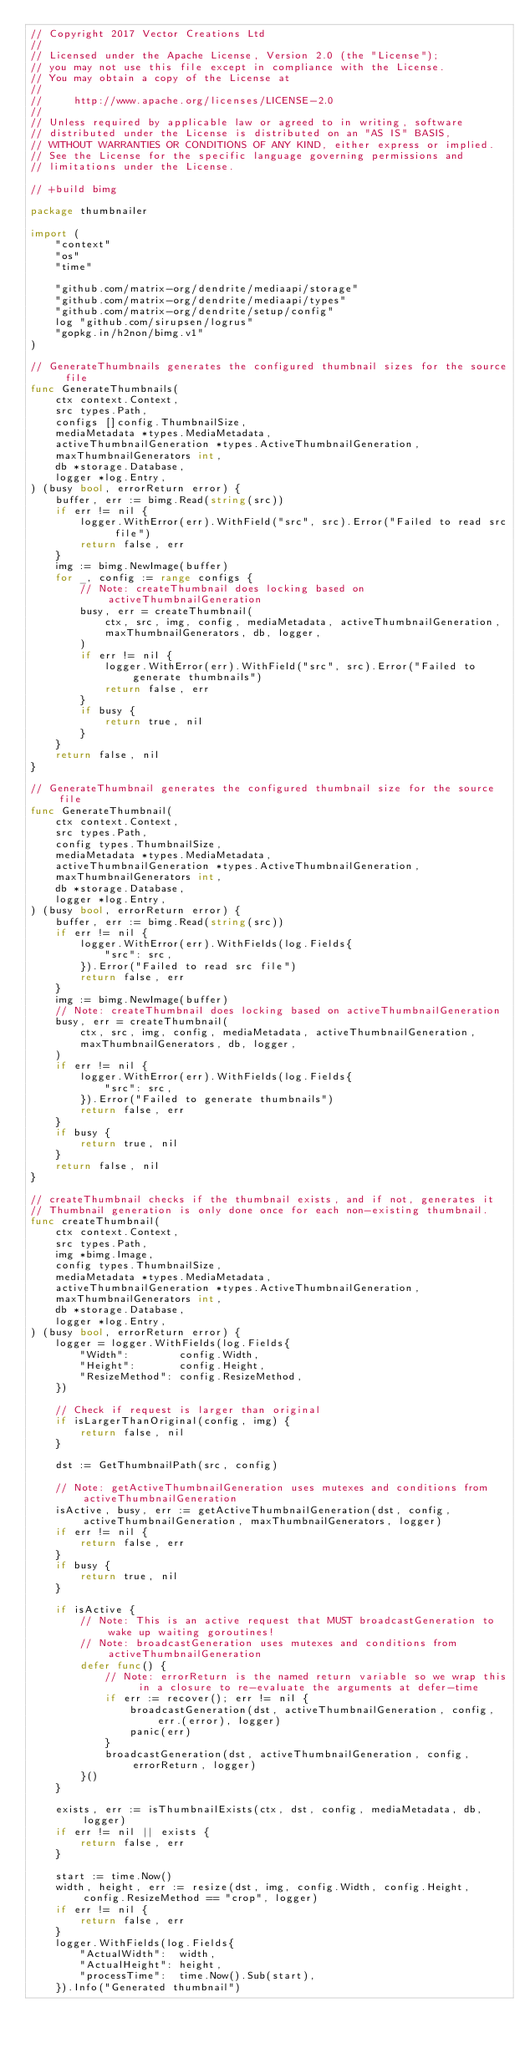<code> <loc_0><loc_0><loc_500><loc_500><_Go_>// Copyright 2017 Vector Creations Ltd
//
// Licensed under the Apache License, Version 2.0 (the "License");
// you may not use this file except in compliance with the License.
// You may obtain a copy of the License at
//
//     http://www.apache.org/licenses/LICENSE-2.0
//
// Unless required by applicable law or agreed to in writing, software
// distributed under the License is distributed on an "AS IS" BASIS,
// WITHOUT WARRANTIES OR CONDITIONS OF ANY KIND, either express or implied.
// See the License for the specific language governing permissions and
// limitations under the License.

// +build bimg

package thumbnailer

import (
	"context"
	"os"
	"time"

	"github.com/matrix-org/dendrite/mediaapi/storage"
	"github.com/matrix-org/dendrite/mediaapi/types"
	"github.com/matrix-org/dendrite/setup/config"
	log "github.com/sirupsen/logrus"
	"gopkg.in/h2non/bimg.v1"
)

// GenerateThumbnails generates the configured thumbnail sizes for the source file
func GenerateThumbnails(
	ctx context.Context,
	src types.Path,
	configs []config.ThumbnailSize,
	mediaMetadata *types.MediaMetadata,
	activeThumbnailGeneration *types.ActiveThumbnailGeneration,
	maxThumbnailGenerators int,
	db *storage.Database,
	logger *log.Entry,
) (busy bool, errorReturn error) {
	buffer, err := bimg.Read(string(src))
	if err != nil {
		logger.WithError(err).WithField("src", src).Error("Failed to read src file")
		return false, err
	}
	img := bimg.NewImage(buffer)
	for _, config := range configs {
		// Note: createThumbnail does locking based on activeThumbnailGeneration
		busy, err = createThumbnail(
			ctx, src, img, config, mediaMetadata, activeThumbnailGeneration,
			maxThumbnailGenerators, db, logger,
		)
		if err != nil {
			logger.WithError(err).WithField("src", src).Error("Failed to generate thumbnails")
			return false, err
		}
		if busy {
			return true, nil
		}
	}
	return false, nil
}

// GenerateThumbnail generates the configured thumbnail size for the source file
func GenerateThumbnail(
	ctx context.Context,
	src types.Path,
	config types.ThumbnailSize,
	mediaMetadata *types.MediaMetadata,
	activeThumbnailGeneration *types.ActiveThumbnailGeneration,
	maxThumbnailGenerators int,
	db *storage.Database,
	logger *log.Entry,
) (busy bool, errorReturn error) {
	buffer, err := bimg.Read(string(src))
	if err != nil {
		logger.WithError(err).WithFields(log.Fields{
			"src": src,
		}).Error("Failed to read src file")
		return false, err
	}
	img := bimg.NewImage(buffer)
	// Note: createThumbnail does locking based on activeThumbnailGeneration
	busy, err = createThumbnail(
		ctx, src, img, config, mediaMetadata, activeThumbnailGeneration,
		maxThumbnailGenerators, db, logger,
	)
	if err != nil {
		logger.WithError(err).WithFields(log.Fields{
			"src": src,
		}).Error("Failed to generate thumbnails")
		return false, err
	}
	if busy {
		return true, nil
	}
	return false, nil
}

// createThumbnail checks if the thumbnail exists, and if not, generates it
// Thumbnail generation is only done once for each non-existing thumbnail.
func createThumbnail(
	ctx context.Context,
	src types.Path,
	img *bimg.Image,
	config types.ThumbnailSize,
	mediaMetadata *types.MediaMetadata,
	activeThumbnailGeneration *types.ActiveThumbnailGeneration,
	maxThumbnailGenerators int,
	db *storage.Database,
	logger *log.Entry,
) (busy bool, errorReturn error) {
	logger = logger.WithFields(log.Fields{
		"Width":        config.Width,
		"Height":       config.Height,
		"ResizeMethod": config.ResizeMethod,
	})

	// Check if request is larger than original
	if isLargerThanOriginal(config, img) {
		return false, nil
	}

	dst := GetThumbnailPath(src, config)

	// Note: getActiveThumbnailGeneration uses mutexes and conditions from activeThumbnailGeneration
	isActive, busy, err := getActiveThumbnailGeneration(dst, config, activeThumbnailGeneration, maxThumbnailGenerators, logger)
	if err != nil {
		return false, err
	}
	if busy {
		return true, nil
	}

	if isActive {
		// Note: This is an active request that MUST broadcastGeneration to wake up waiting goroutines!
		// Note: broadcastGeneration uses mutexes and conditions from activeThumbnailGeneration
		defer func() {
			// Note: errorReturn is the named return variable so we wrap this in a closure to re-evaluate the arguments at defer-time
			if err := recover(); err != nil {
				broadcastGeneration(dst, activeThumbnailGeneration, config, err.(error), logger)
				panic(err)
			}
			broadcastGeneration(dst, activeThumbnailGeneration, config, errorReturn, logger)
		}()
	}

	exists, err := isThumbnailExists(ctx, dst, config, mediaMetadata, db, logger)
	if err != nil || exists {
		return false, err
	}

	start := time.Now()
	width, height, err := resize(dst, img, config.Width, config.Height, config.ResizeMethod == "crop", logger)
	if err != nil {
		return false, err
	}
	logger.WithFields(log.Fields{
		"ActualWidth":  width,
		"ActualHeight": height,
		"processTime":  time.Now().Sub(start),
	}).Info("Generated thumbnail")
</code> 